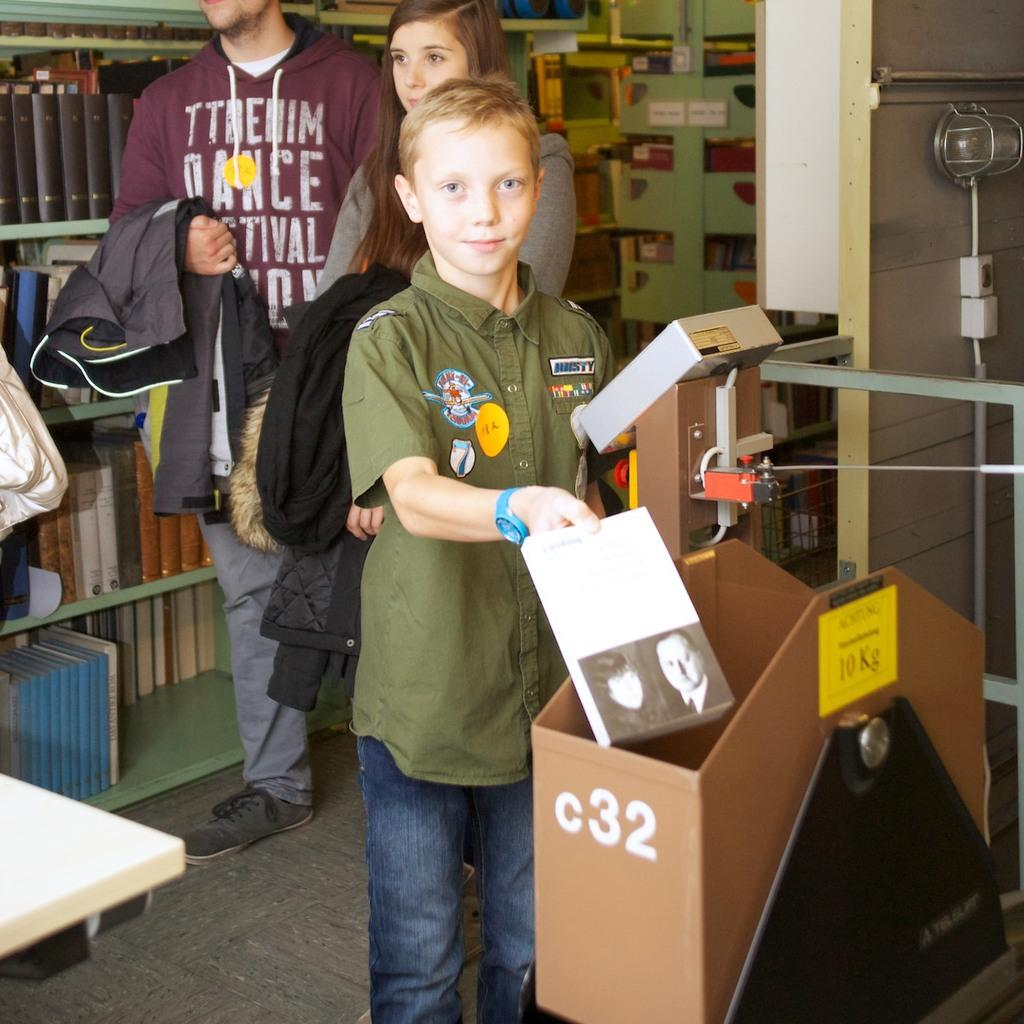What is the person holding in the image? The person is holding something in the image, but the specific object is not mentioned in the facts. What can be seen in the background of the image? There are book racks visible in the background, and there are objects around the book racks. How many people are standing in the background? Two people are standing in the background. What type of ornament is hanging from the shoe of the person in the image? There is no mention of an ornament or a shoe in the image, so it cannot be determined if there is an ornament hanging from a shoe. 